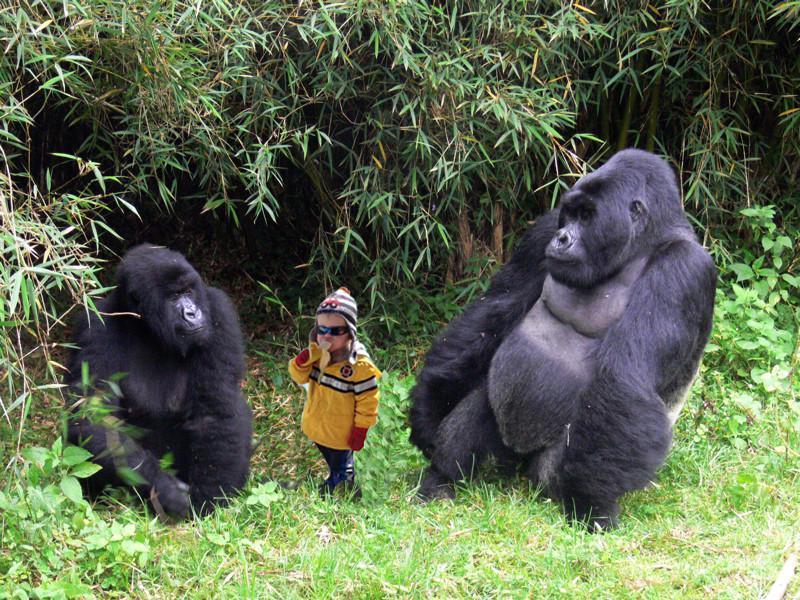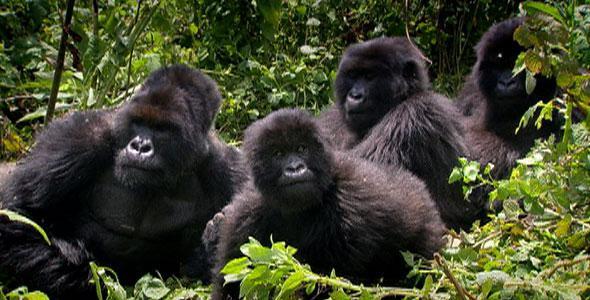The first image is the image on the left, the second image is the image on the right. For the images displayed, is the sentence "There's no more than four gorillas in the right image." factually correct? Answer yes or no. Yes. The first image is the image on the left, the second image is the image on the right. Evaluate the accuracy of this statement regarding the images: "There are six gorillas in the image pair.". Is it true? Answer yes or no. Yes. 